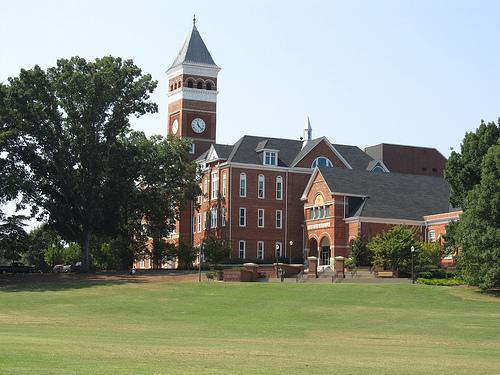Question: where is the building standing?
Choices:
A. At the bottom of a hill.
B. Across the street.
C. At the end of a long set of stairs.
D. On a hill.
Answer with the letter. Answer: D Question: how is the building constructed?
Choices:
A. With steel.
B. On stilts.
C. With concrete.
D. Out of brick.
Answer with the letter. Answer: D Question: where are the trees?
Choices:
A. On either side of the stairs.
B. Around the fountain.
C. Planted along the sidewalk.
D. Surrounding the building.
Answer with the letter. Answer: D Question: where is the clock?
Choices:
A. One the wall.
B. On the night stand.
C. On the tower.
D. On the shelf.
Answer with the letter. Answer: C Question: what color are the building's shingles?
Choices:
A. Green.
B. Black.
C. Red.
D. Orange.
Answer with the letter. Answer: B 